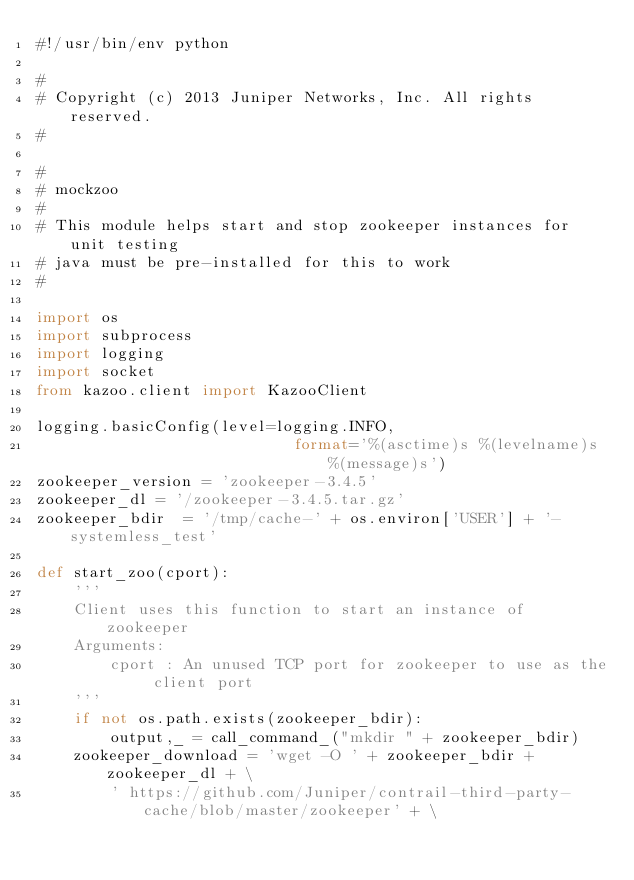<code> <loc_0><loc_0><loc_500><loc_500><_Python_>#!/usr/bin/env python

#
# Copyright (c) 2013 Juniper Networks, Inc. All rights reserved.
#

#
# mockzoo
#
# This module helps start and stop zookeeper instances for unit testing
# java must be pre-installed for this to work
#
    
import os
import subprocess
import logging
import socket
from kazoo.client import KazooClient

logging.basicConfig(level=logging.INFO,
                            format='%(asctime)s %(levelname)s %(message)s')
zookeeper_version = 'zookeeper-3.4.5'
zookeeper_dl = '/zookeeper-3.4.5.tar.gz'
zookeeper_bdir  = '/tmp/cache-' + os.environ['USER'] + '-systemless_test'

def start_zoo(cport):
    '''
    Client uses this function to start an instance of zookeeper
    Arguments:
        cport : An unused TCP port for zookeeper to use as the client port
    '''
    if not os.path.exists(zookeeper_bdir):
        output,_ = call_command_("mkdir " + zookeeper_bdir)
    zookeeper_download = 'wget -O ' + zookeeper_bdir + zookeeper_dl + \
        ' https://github.com/Juniper/contrail-third-party-cache/blob/master/zookeeper' + \</code> 